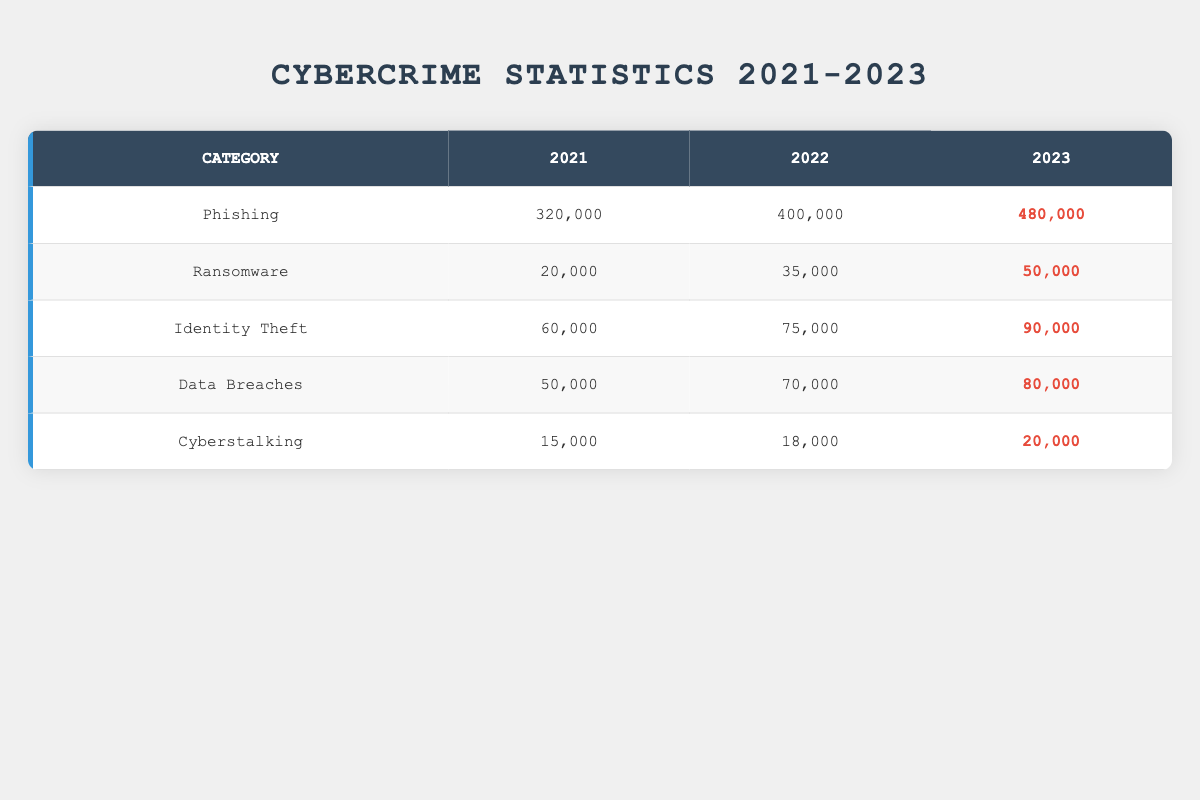What was the total number of phishing incidents reported in 2022? The table shows that in 2022, the number of phishing incidents was 400,000.
Answer: 400,000 Which category of cybercrime had the highest increase from 2021 to 2023? To find the category with the highest increase, we calculate the difference for each category: Phishing (480,000 - 320,000 = 160,000), Ransomware (50,000 - 20,000 = 30,000), Identity Theft (90,000 - 60,000 = 30,000), Data Breaches (80,000 - 50,000 = 30,000), Cyberstalking (20,000 - 15,000 = 5,000). The largest increase is in Phishing with an increase of 160,000.
Answer: Phishing Is the number of ransomware incidents higher in 2023 than in 2022? The data shows that in 2022, there were 35,000 ransomware incidents, and in 2023, there are 50,000. Since 50,000 is greater than 35,000, the statement is true.
Answer: Yes What is the average number of data breaches reported from 2021 to 2023? To find the average, we sum the data breaches for all three years: (50,000 + 70,000 + 80,000) = 200,000. We then divide by the number of years, which is 3, giving us an average of 200,000 / 3 = 66,667.
Answer: 66,667 Did identity theft incidents decrease over the years? Looking at the data, identity theft incidents increased from 60,000 in 2021 to 75,000 in 2022, and then to 90,000 in 2023. Therefore, it did not decrease; it actually increased each year.
Answer: No Which category experienced the lowest total number of incidents across the years? Summing the incidents for each category: Phishing (320,000 + 400,000 + 480,000 = 1,200,000), Ransomware (20,000 + 35,000 + 50,000 = 105,000), Identity Theft (60,000 + 75,000 + 90,000 = 225,000), Data Breaches (50,000 + 70,000 + 80,000 = 200,000), Cyberstalking (15,000 + 18,000 + 20,000 = 53,000). The lowest total is Cyberstalking with 53,000 incidents.
Answer: Cyberstalking How many more identity theft incidents were reported in 2023 compared to 2021? The number of identity theft incidents in 2023 is 90,000, and in 2021 it was 60,000. The difference is calculated as 90,000 - 60,000 = 30,000.
Answer: 30,000 What was the total number of cyberstalking incidents reported across all years? Adding the incidents from each year: 15,000 (2021) + 18,000 (2022) + 20,000 (2023) totals to 15,000 + 18,000 + 20,000 = 53,000.
Answer: 53,000 Which category had the least number of incidents in 2022? In 2022, the reported incidents were: Phishing (400,000), Ransomware (35,000), Identity Theft (75,000), Data Breaches (70,000), Cyberstalking (18,000). The least number in that year is Ransomware with 35,000 incidents.
Answer: Ransomware 